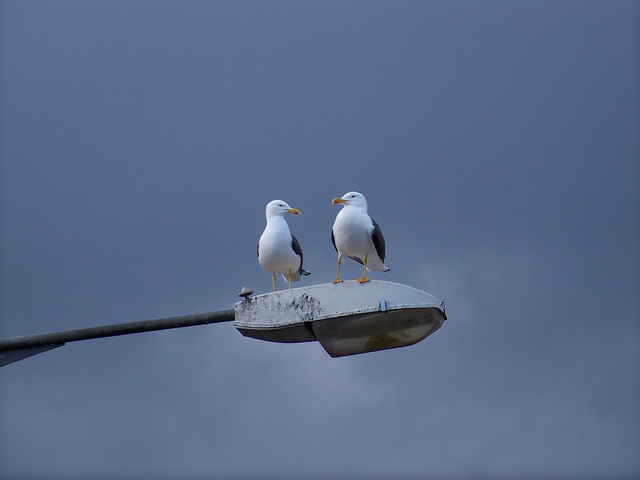Describe the objects in this image and their specific colors. I can see bird in gray and darkgray tones and bird in gray and darkgray tones in this image. 